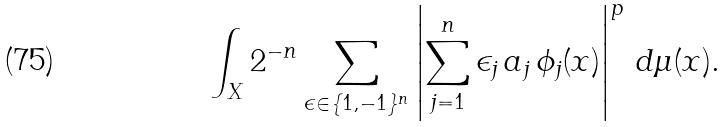Convert formula to latex. <formula><loc_0><loc_0><loc_500><loc_500>\int _ { X } 2 ^ { - n } \sum _ { \epsilon \in \{ 1 , - 1 \} ^ { n } } \left | \sum _ { j = 1 } ^ { n } \epsilon _ { j } \, a _ { j } \, \phi _ { j } ( x ) \right | ^ { p } \, d \mu ( x ) .</formula> 